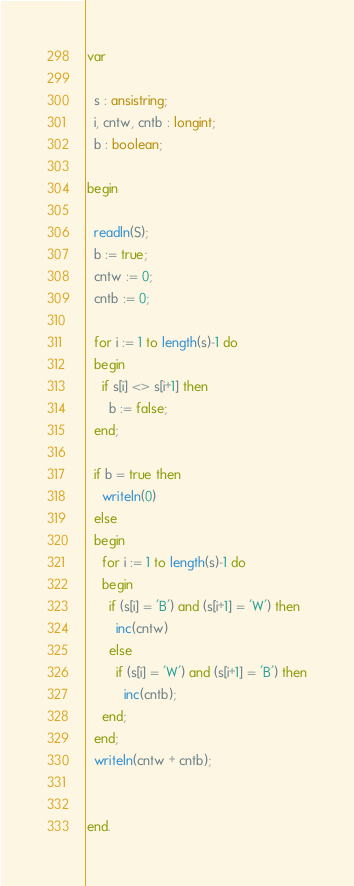Convert code to text. <code><loc_0><loc_0><loc_500><loc_500><_Pascal_>var

  s : ansistring;
  i, cntw, cntb : longint;
  b : boolean;
  
begin

  readln(S);
  b := true;
  cntw := 0;
  cntb := 0;
  
  for i := 1 to length(s)-1 do
  begin
    if s[i] <> s[i+1] then
      b := false;
  end;
  
  if b = true then
    writeln(0)
  else
  begin
    for i := 1 to length(s)-1 do
    begin
      if (s[i] = 'B') and (s[i+1] = 'W') then
        inc(cntw)
      else
        if (s[i] = 'W') and (s[i+1] = 'B') then
          inc(cntb);
    end;
  end;
  writeln(cntw + cntb);
  

end.</code> 